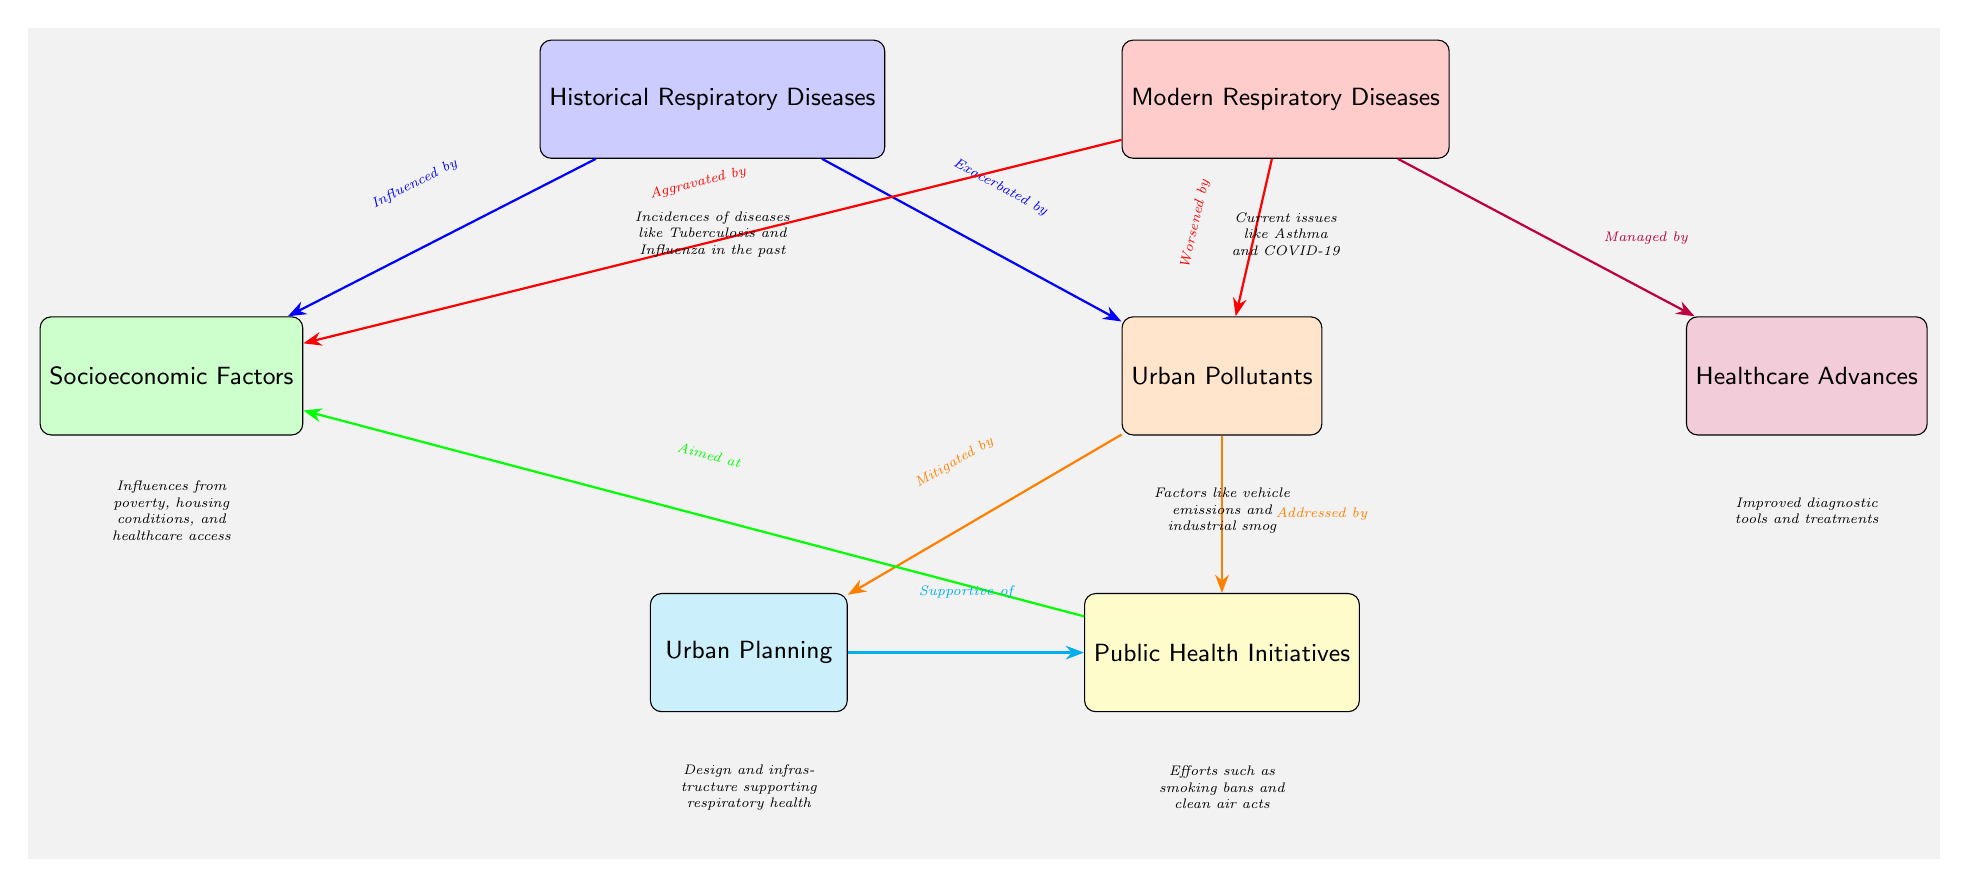What are the two types of respiratory diseases depicted? The diagram identifies "Historical Respiratory Diseases" and "Modern Respiratory Diseases" as the two types, shown as separate nodes.
Answer: Historical Respiratory Diseases and Modern Respiratory Diseases How many factors are listed that contribute to respiratory diseases? The diagram outlines three contributing factors: "Urban Pollutants," "Socioeconomic Factors," and "Healthcare Advances." Counting the nodes aligned with these factors provides the total.
Answer: Three factors What type of respiratory disease was exacerbated by urban pollutants historically? The connection labeled "Exacerbated by" between "Historical Respiratory Diseases" and "Urban Pollutants" indicates that urban pollutants worsened historical diseases.
Answer: Historical Respiratory Diseases Which modern respiratory disease is mentioned in the diagram? The "Modern Respiratory Diseases" node mentions current issues like Asthma and COVID-19; the connection to modern times implies both are included.
Answer: Asthma and COVID-19 What supports public health initiatives aimed at urban pollutants? The node for "Urban Planning" indicates the supportive role in the mitigation of urban pollutants through effective design and infrastructure.
Answer: Urban Planning Which historic disease is represented in the node description? The description associated with "Historical Respiratory Diseases" specifically mentions diseases like Tuberculosis and Influenza that were common in the past.
Answer: Tuberculosis and Influenza How are healthcare advances related to modern respiratory diseases? The diagram shows a "Managed by" relationship between "Modern Respiratory Diseases" and "Healthcare Advances," indicating that advances in healthcare directly address these diseases.
Answer: Managed by What public health initiatives are related to urban pollutants? The connection labeled "Addressed by" links "Urban Pollutants" to "Public Health Initiatives," suggesting that these initiatives are ways to combat pollution effects.
Answer: Public Health Initiatives In the context of socioeconomic factors, what is aimed at improving health outcomes? The labeled connection "Aimed at" between "Public Health Initiatives" and "Socioeconomic Factors" suggests these initiatives focus on improving socioeconomic conditions to enhance health outcomes.
Answer: Aimed at 